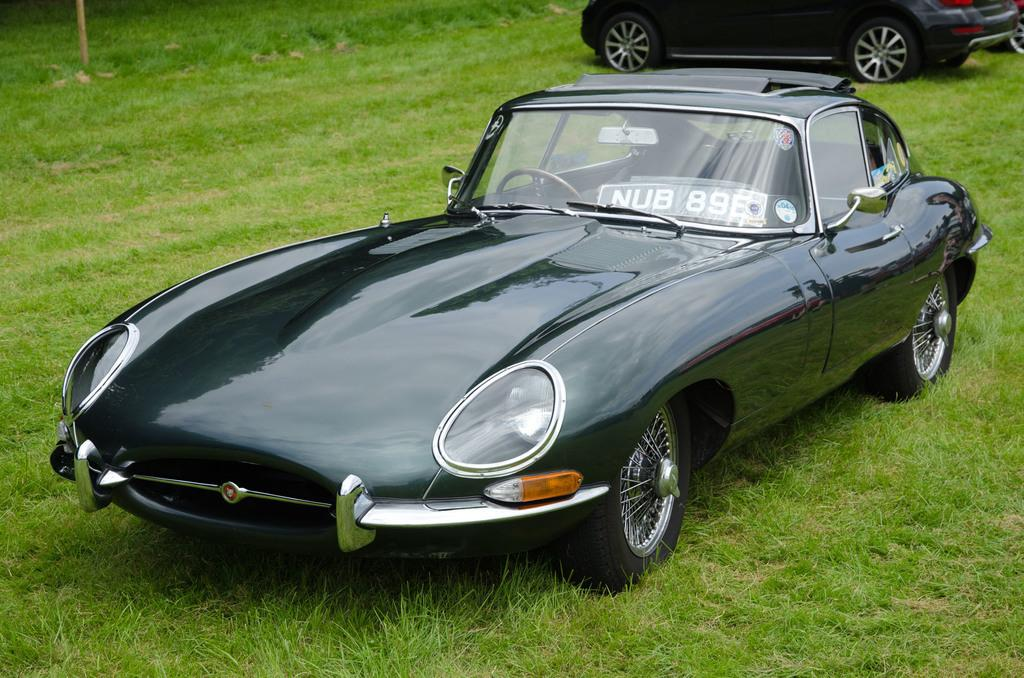What is the primary color of the grassland in the image? The grassland in the image is primarily green. How many cars are present on the grassland? There are two black cars on the grassland. Is there a zoo visible in the image? There is no mention of a zoo in the provided facts, and therefore it cannot be determined if one is present in the image. 